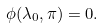Convert formula to latex. <formula><loc_0><loc_0><loc_500><loc_500>\phi ( \lambda _ { 0 } , \pi ) = 0 .</formula> 